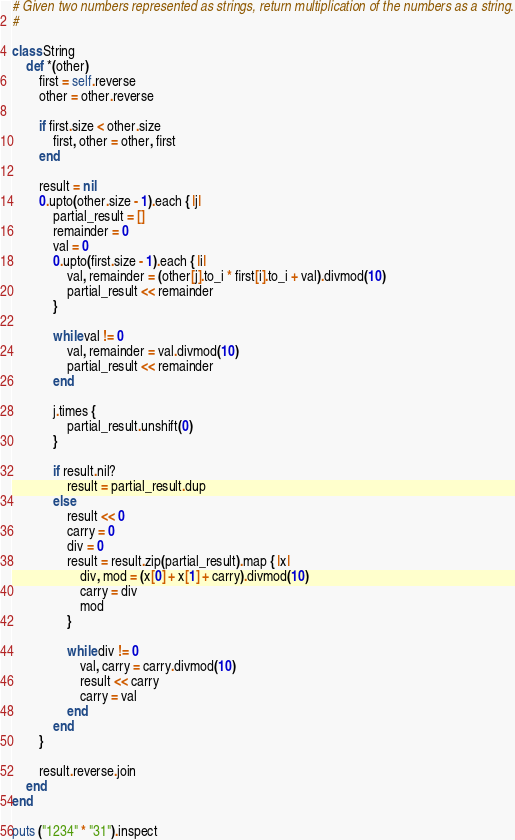Convert code to text. <code><loc_0><loc_0><loc_500><loc_500><_Ruby_># Given two numbers represented as strings, return multiplication of the numbers as a string.
#

class String
    def *(other)
        first = self.reverse
        other = other.reverse
        
        if first.size < other.size
            first, other = other, first
        end

        result = nil
        0.upto(other.size - 1).each { |j|
            partial_result = []
            remainder = 0
            val = 0
            0.upto(first.size - 1).each { |i|
                val, remainder = (other[j].to_i * first[i].to_i + val).divmod(10)
                partial_result << remainder
            }

            while val != 0
                val, remainder = val.divmod(10)
                partial_result << remainder
            end

            j.times {
                partial_result.unshift(0)
            }
            
            if result.nil?
                result = partial_result.dup
            else
                result << 0
                carry = 0
                div = 0
                result = result.zip(partial_result).map { |x|
                    div, mod = (x[0] + x[1] + carry).divmod(10)
                    carry = div
                    mod
                }

                while div != 0
                    val, carry = carry.divmod(10)
                    result << carry
                    carry = val
                end
            end
        }

        result.reverse.join
    end
end

puts ("1234" * "31").inspect
</code> 